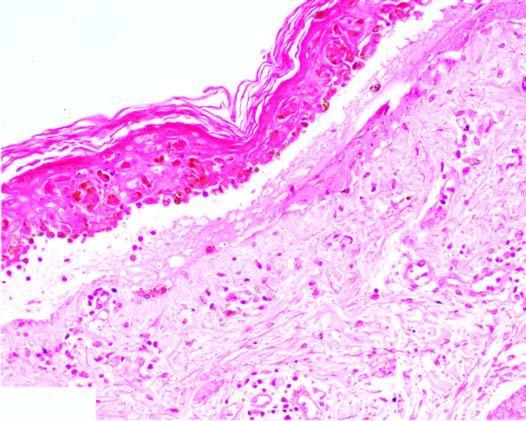s there oedema and necrosis of kertinocytes at the junction and mild lymphocytic infiltrate?
Answer the question using a single word or phrase. Yes 